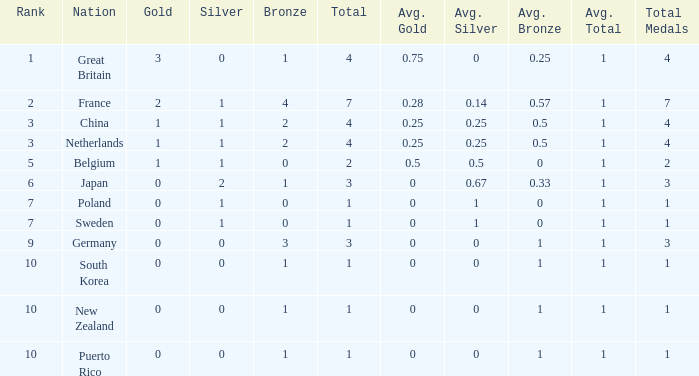What is the rank with 0 bronze? None. 